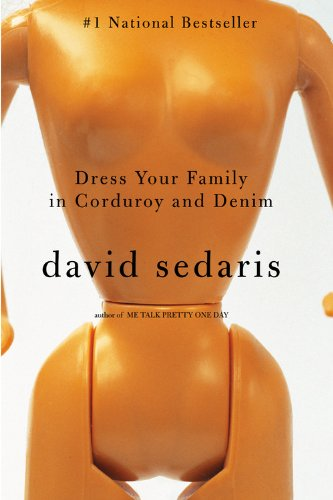Is this book related to Humor & Entertainment? Yes, this book is categorically related to Humor & Entertainment, showcasing David Sedaris's exceptional skill in crafting engaging and humorous narratives. 